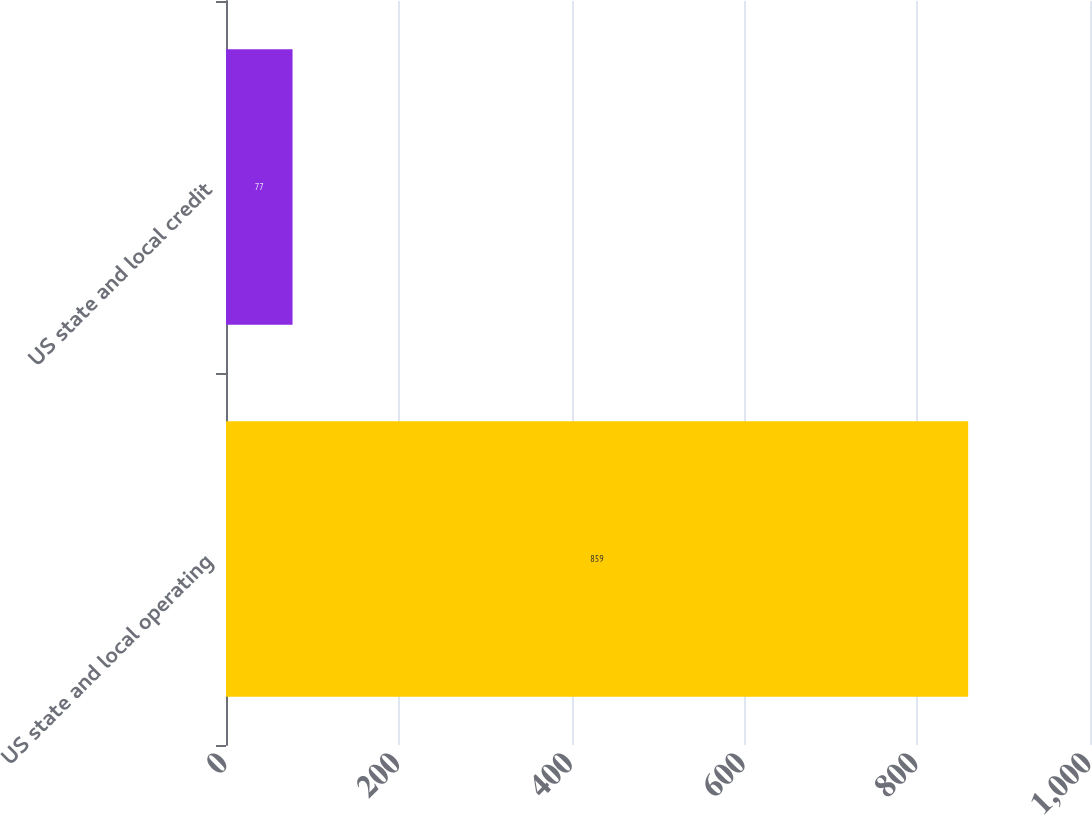Convert chart to OTSL. <chart><loc_0><loc_0><loc_500><loc_500><bar_chart><fcel>US state and local operating<fcel>US state and local credit<nl><fcel>859<fcel>77<nl></chart> 